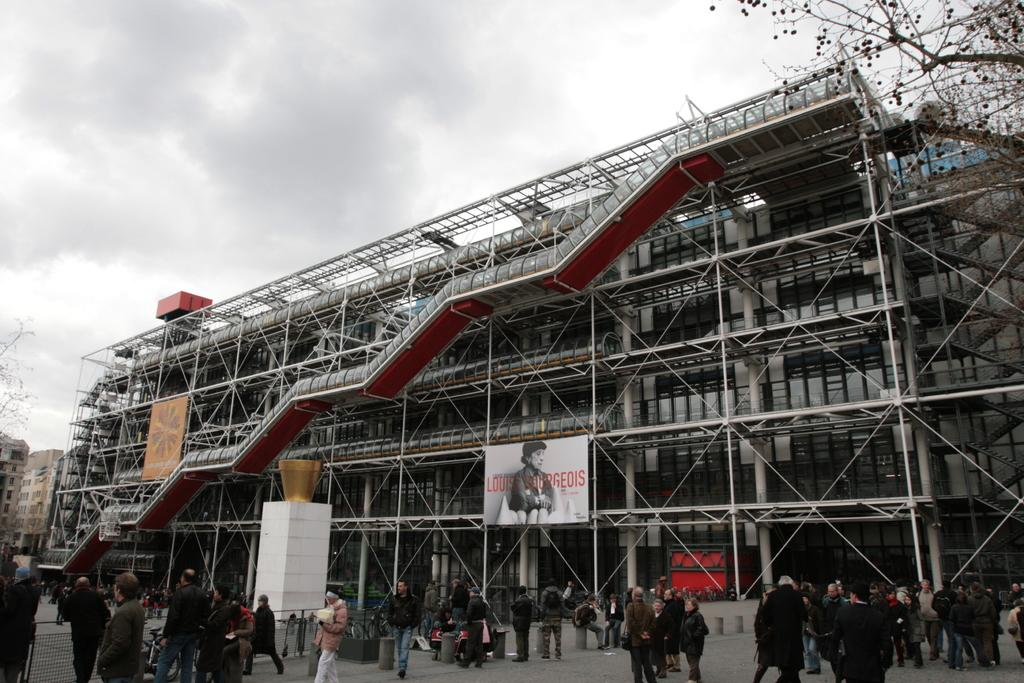What type of structure is present in the image? There is a building in the image. Who or what can be seen at the bottom of the image? There are people at the bottom of the image. What is visible at the top of the image? The sky is visible at the top of the image. What type of vegetation is on the sides of the image? There are trees on both the left and right sides of the image. What type of horn can be seen on the building in the image? There is no horn present on the building in the image. What is the hammer used for in the image? There is no hammer present in the image. 